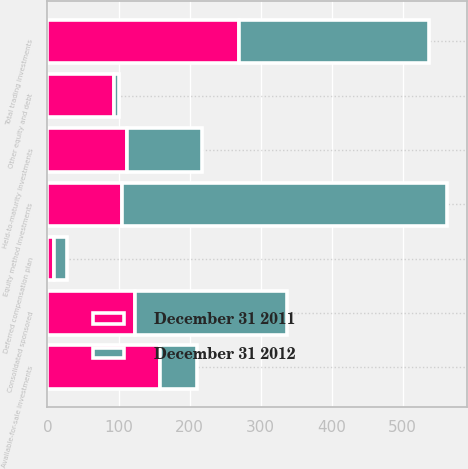<chart> <loc_0><loc_0><loc_500><loc_500><stacked_bar_chart><ecel><fcel>Available-for-sale investments<fcel>Held-to-maturity investments<fcel>Consolidated sponsored<fcel>Other equity and debt<fcel>Deferred compensation plan<fcel>Total trading investments<fcel>Equity method investments<nl><fcel>December 31 2011<fcel>158<fcel>112<fcel>123<fcel>94<fcel>9<fcel>270<fcel>105<nl><fcel>December 31 2012<fcel>52<fcel>105<fcel>214<fcel>7<fcel>19<fcel>267<fcel>457<nl></chart> 